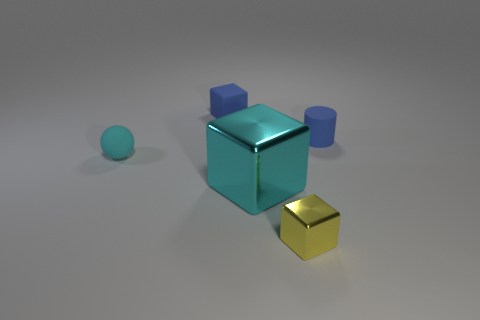There is a blue matte object that is the same shape as the large metallic thing; what size is it?
Offer a terse response. Small. Are there any other things that have the same size as the blue cube?
Ensure brevity in your answer.  Yes. There is a blue thing that is right of the tiny blue matte object on the left side of the blue object on the right side of the tiny blue cube; what is it made of?
Offer a very short reply. Rubber. Are there more big things left of the tiny matte block than metallic things that are behind the yellow thing?
Provide a short and direct response. No. Do the blue rubber block and the cyan block have the same size?
Give a very brief answer. No. There is another rubber object that is the same shape as the big thing; what is its color?
Your answer should be very brief. Blue. What number of spheres have the same color as the tiny cylinder?
Offer a very short reply. 0. Are there more tiny yellow blocks that are behind the big thing than tiny metal things?
Provide a short and direct response. No. The small thing in front of the cyan thing on the left side of the large shiny object is what color?
Provide a succinct answer. Yellow. What number of things are either tiny things that are behind the sphere or small blocks in front of the cyan sphere?
Offer a terse response. 3. 